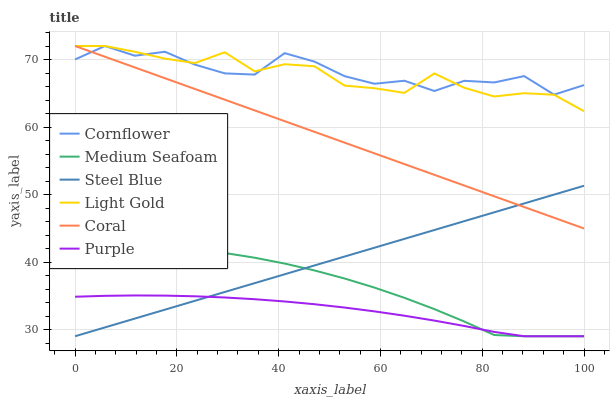Does Purple have the minimum area under the curve?
Answer yes or no. Yes. Does Cornflower have the maximum area under the curve?
Answer yes or no. Yes. Does Coral have the minimum area under the curve?
Answer yes or no. No. Does Coral have the maximum area under the curve?
Answer yes or no. No. Is Steel Blue the smoothest?
Answer yes or no. Yes. Is Cornflower the roughest?
Answer yes or no. Yes. Is Purple the smoothest?
Answer yes or no. No. Is Purple the roughest?
Answer yes or no. No. Does Coral have the lowest value?
Answer yes or no. No. Does Light Gold have the highest value?
Answer yes or no. Yes. Does Purple have the highest value?
Answer yes or no. No. Is Medium Seafoam less than Cornflower?
Answer yes or no. Yes. Is Light Gold greater than Purple?
Answer yes or no. Yes. Does Purple intersect Medium Seafoam?
Answer yes or no. Yes. Is Purple less than Medium Seafoam?
Answer yes or no. No. Is Purple greater than Medium Seafoam?
Answer yes or no. No. Does Medium Seafoam intersect Cornflower?
Answer yes or no. No. 